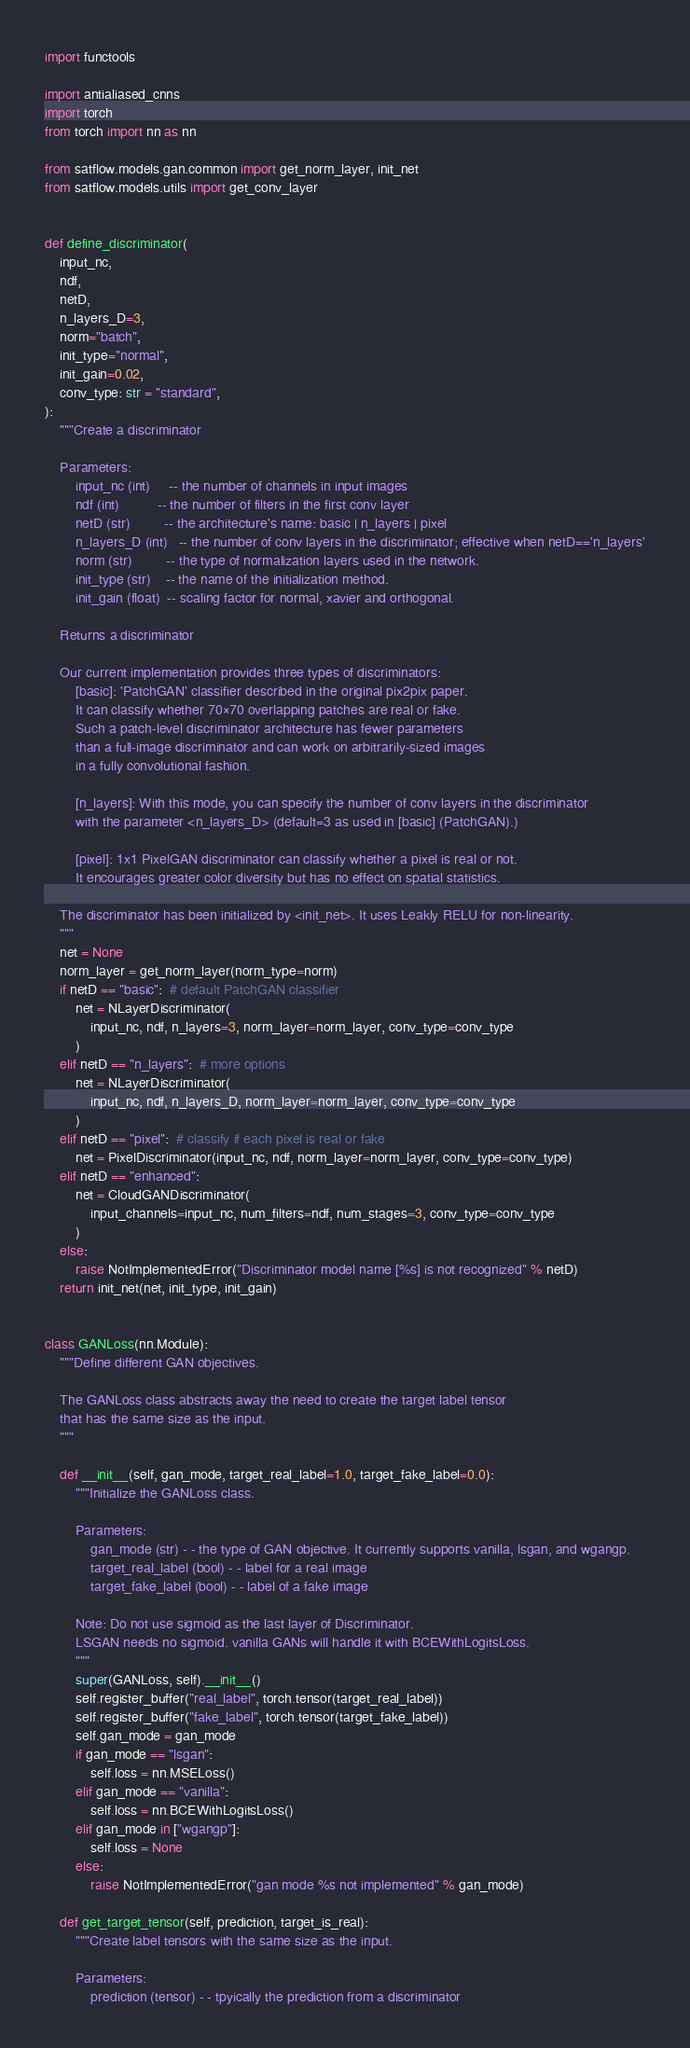<code> <loc_0><loc_0><loc_500><loc_500><_Python_>import functools

import antialiased_cnns
import torch
from torch import nn as nn

from satflow.models.gan.common import get_norm_layer, init_net
from satflow.models.utils import get_conv_layer


def define_discriminator(
    input_nc,
    ndf,
    netD,
    n_layers_D=3,
    norm="batch",
    init_type="normal",
    init_gain=0.02,
    conv_type: str = "standard",
):
    """Create a discriminator

    Parameters:
        input_nc (int)     -- the number of channels in input images
        ndf (int)          -- the number of filters in the first conv layer
        netD (str)         -- the architecture's name: basic | n_layers | pixel
        n_layers_D (int)   -- the number of conv layers in the discriminator; effective when netD=='n_layers'
        norm (str)         -- the type of normalization layers used in the network.
        init_type (str)    -- the name of the initialization method.
        init_gain (float)  -- scaling factor for normal, xavier and orthogonal.

    Returns a discriminator

    Our current implementation provides three types of discriminators:
        [basic]: 'PatchGAN' classifier described in the original pix2pix paper.
        It can classify whether 70×70 overlapping patches are real or fake.
        Such a patch-level discriminator architecture has fewer parameters
        than a full-image discriminator and can work on arbitrarily-sized images
        in a fully convolutional fashion.

        [n_layers]: With this mode, you can specify the number of conv layers in the discriminator
        with the parameter <n_layers_D> (default=3 as used in [basic] (PatchGAN).)

        [pixel]: 1x1 PixelGAN discriminator can classify whether a pixel is real or not.
        It encourages greater color diversity but has no effect on spatial statistics.

    The discriminator has been initialized by <init_net>. It uses Leakly RELU for non-linearity.
    """
    net = None
    norm_layer = get_norm_layer(norm_type=norm)
    if netD == "basic":  # default PatchGAN classifier
        net = NLayerDiscriminator(
            input_nc, ndf, n_layers=3, norm_layer=norm_layer, conv_type=conv_type
        )
    elif netD == "n_layers":  # more options
        net = NLayerDiscriminator(
            input_nc, ndf, n_layers_D, norm_layer=norm_layer, conv_type=conv_type
        )
    elif netD == "pixel":  # classify if each pixel is real or fake
        net = PixelDiscriminator(input_nc, ndf, norm_layer=norm_layer, conv_type=conv_type)
    elif netD == "enhanced":
        net = CloudGANDiscriminator(
            input_channels=input_nc, num_filters=ndf, num_stages=3, conv_type=conv_type
        )
    else:
        raise NotImplementedError("Discriminator model name [%s] is not recognized" % netD)
    return init_net(net, init_type, init_gain)


class GANLoss(nn.Module):
    """Define different GAN objectives.

    The GANLoss class abstracts away the need to create the target label tensor
    that has the same size as the input.
    """

    def __init__(self, gan_mode, target_real_label=1.0, target_fake_label=0.0):
        """Initialize the GANLoss class.

        Parameters:
            gan_mode (str) - - the type of GAN objective. It currently supports vanilla, lsgan, and wgangp.
            target_real_label (bool) - - label for a real image
            target_fake_label (bool) - - label of a fake image

        Note: Do not use sigmoid as the last layer of Discriminator.
        LSGAN needs no sigmoid. vanilla GANs will handle it with BCEWithLogitsLoss.
        """
        super(GANLoss, self).__init__()
        self.register_buffer("real_label", torch.tensor(target_real_label))
        self.register_buffer("fake_label", torch.tensor(target_fake_label))
        self.gan_mode = gan_mode
        if gan_mode == "lsgan":
            self.loss = nn.MSELoss()
        elif gan_mode == "vanilla":
            self.loss = nn.BCEWithLogitsLoss()
        elif gan_mode in ["wgangp"]:
            self.loss = None
        else:
            raise NotImplementedError("gan mode %s not implemented" % gan_mode)

    def get_target_tensor(self, prediction, target_is_real):
        """Create label tensors with the same size as the input.

        Parameters:
            prediction (tensor) - - tpyically the prediction from a discriminator</code> 